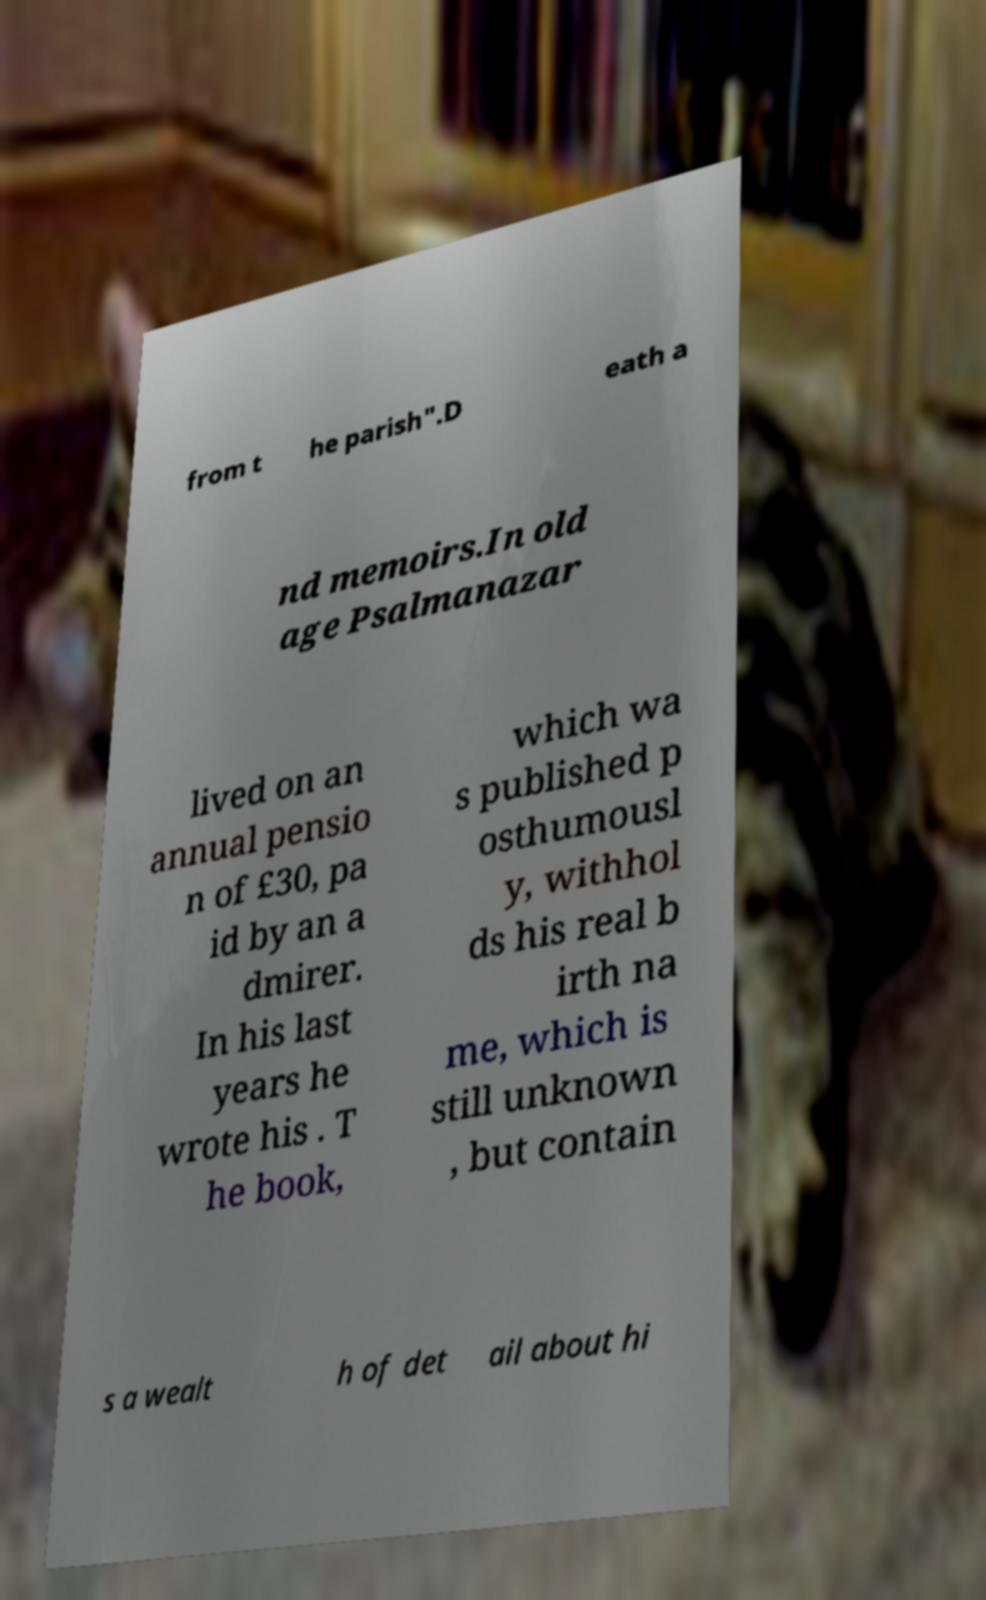For documentation purposes, I need the text within this image transcribed. Could you provide that? from t he parish".D eath a nd memoirs.In old age Psalmanazar lived on an annual pensio n of £30, pa id by an a dmirer. In his last years he wrote his . T he book, which wa s published p osthumousl y, withhol ds his real b irth na me, which is still unknown , but contain s a wealt h of det ail about hi 